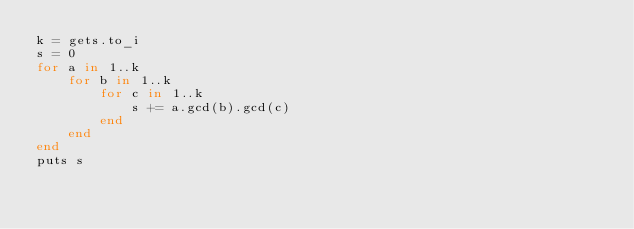Convert code to text. <code><loc_0><loc_0><loc_500><loc_500><_Ruby_>k = gets.to_i
s = 0
for a in 1..k
    for b in 1..k
        for c in 1..k
            s += a.gcd(b).gcd(c)
        end
    end
end
puts s
</code> 